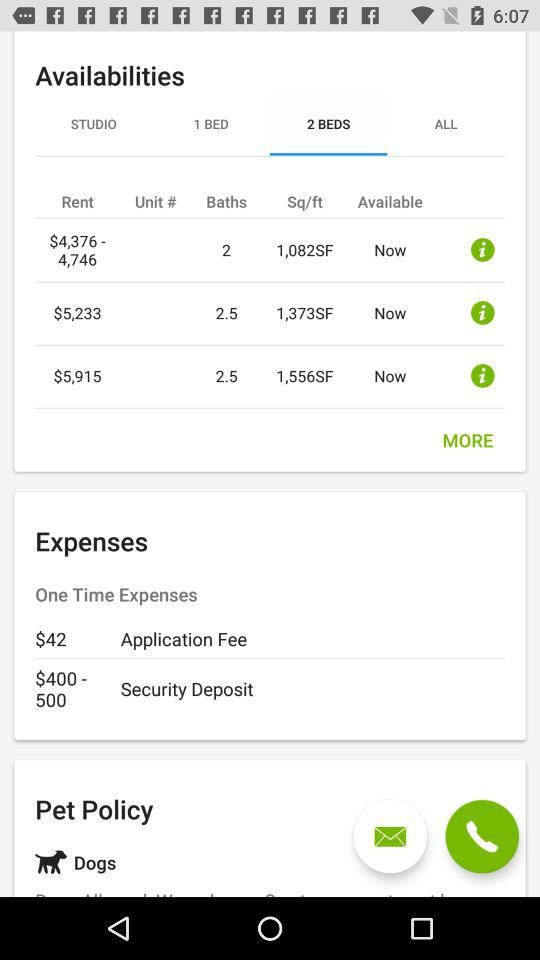What is the number of beds?
When the provided information is insufficient, respond with <no answer>. <no answer> 